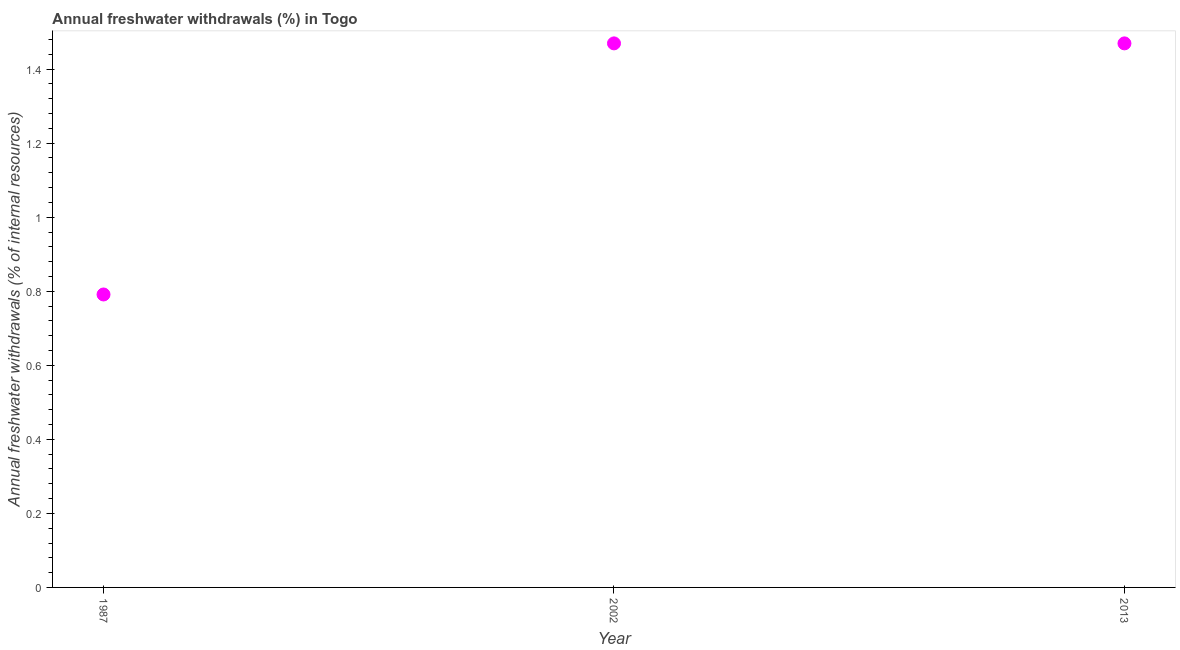What is the annual freshwater withdrawals in 1987?
Offer a very short reply. 0.79. Across all years, what is the maximum annual freshwater withdrawals?
Provide a succinct answer. 1.47. Across all years, what is the minimum annual freshwater withdrawals?
Provide a short and direct response. 0.79. In which year was the annual freshwater withdrawals maximum?
Ensure brevity in your answer.  2002. What is the sum of the annual freshwater withdrawals?
Your answer should be compact. 3.73. What is the difference between the annual freshwater withdrawals in 1987 and 2013?
Give a very brief answer. -0.68. What is the average annual freshwater withdrawals per year?
Provide a succinct answer. 1.24. What is the median annual freshwater withdrawals?
Give a very brief answer. 1.47. In how many years, is the annual freshwater withdrawals greater than 0.52 %?
Your answer should be very brief. 3. Do a majority of the years between 1987 and 2013 (inclusive) have annual freshwater withdrawals greater than 0.28 %?
Provide a short and direct response. Yes. What is the ratio of the annual freshwater withdrawals in 1987 to that in 2002?
Ensure brevity in your answer.  0.54. What is the difference between the highest and the second highest annual freshwater withdrawals?
Your answer should be compact. 0. Is the sum of the annual freshwater withdrawals in 1987 and 2002 greater than the maximum annual freshwater withdrawals across all years?
Offer a very short reply. Yes. What is the difference between the highest and the lowest annual freshwater withdrawals?
Make the answer very short. 0.68. In how many years, is the annual freshwater withdrawals greater than the average annual freshwater withdrawals taken over all years?
Offer a terse response. 2. How many dotlines are there?
Give a very brief answer. 1. How many years are there in the graph?
Your response must be concise. 3. What is the difference between two consecutive major ticks on the Y-axis?
Provide a succinct answer. 0.2. Does the graph contain grids?
Ensure brevity in your answer.  No. What is the title of the graph?
Offer a terse response. Annual freshwater withdrawals (%) in Togo. What is the label or title of the Y-axis?
Provide a succinct answer. Annual freshwater withdrawals (% of internal resources). What is the Annual freshwater withdrawals (% of internal resources) in 1987?
Provide a short and direct response. 0.79. What is the Annual freshwater withdrawals (% of internal resources) in 2002?
Provide a short and direct response. 1.47. What is the Annual freshwater withdrawals (% of internal resources) in 2013?
Keep it short and to the point. 1.47. What is the difference between the Annual freshwater withdrawals (% of internal resources) in 1987 and 2002?
Keep it short and to the point. -0.68. What is the difference between the Annual freshwater withdrawals (% of internal resources) in 1987 and 2013?
Your response must be concise. -0.68. What is the difference between the Annual freshwater withdrawals (% of internal resources) in 2002 and 2013?
Provide a succinct answer. 0. What is the ratio of the Annual freshwater withdrawals (% of internal resources) in 1987 to that in 2002?
Provide a short and direct response. 0.54. What is the ratio of the Annual freshwater withdrawals (% of internal resources) in 1987 to that in 2013?
Give a very brief answer. 0.54. 